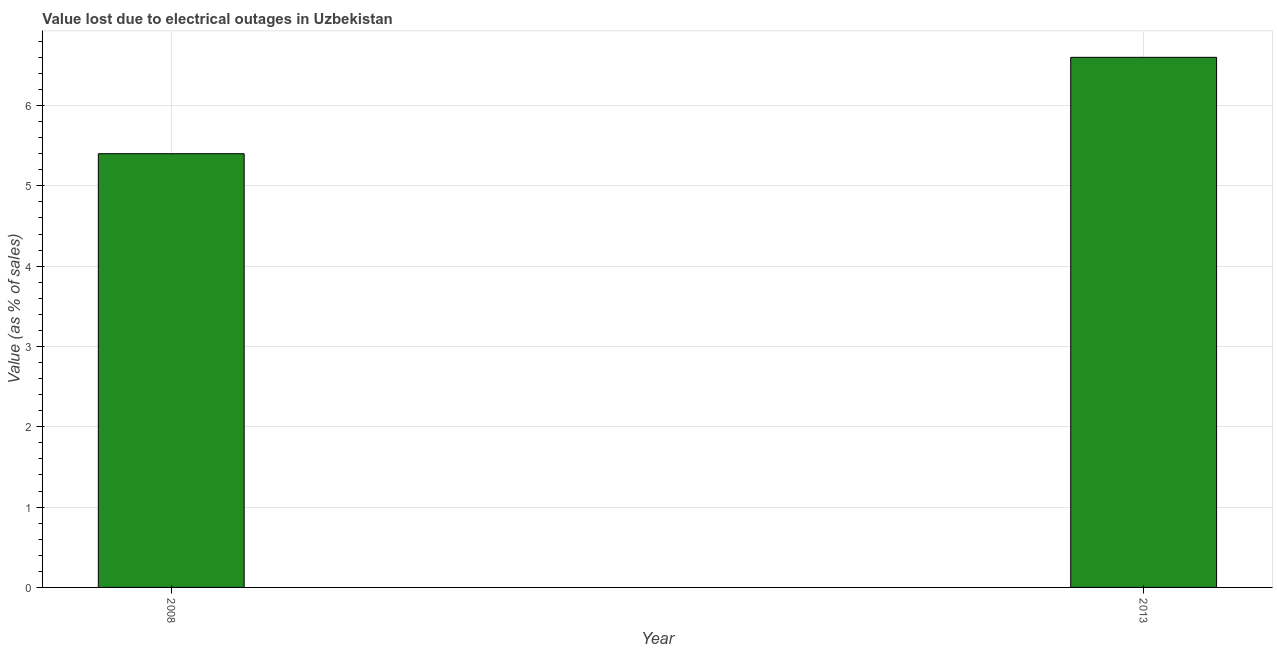Does the graph contain any zero values?
Your answer should be very brief. No. What is the title of the graph?
Offer a very short reply. Value lost due to electrical outages in Uzbekistan. What is the label or title of the X-axis?
Make the answer very short. Year. What is the label or title of the Y-axis?
Offer a very short reply. Value (as % of sales). What is the value lost due to electrical outages in 2013?
Ensure brevity in your answer.  6.6. Across all years, what is the maximum value lost due to electrical outages?
Your answer should be very brief. 6.6. Across all years, what is the minimum value lost due to electrical outages?
Offer a terse response. 5.4. In which year was the value lost due to electrical outages minimum?
Keep it short and to the point. 2008. What is the sum of the value lost due to electrical outages?
Your response must be concise. 12. What is the average value lost due to electrical outages per year?
Offer a very short reply. 6. Do a majority of the years between 2008 and 2013 (inclusive) have value lost due to electrical outages greater than 5.4 %?
Provide a succinct answer. No. What is the ratio of the value lost due to electrical outages in 2008 to that in 2013?
Ensure brevity in your answer.  0.82. Is the value lost due to electrical outages in 2008 less than that in 2013?
Offer a very short reply. Yes. In how many years, is the value lost due to electrical outages greater than the average value lost due to electrical outages taken over all years?
Provide a succinct answer. 1. What is the difference between two consecutive major ticks on the Y-axis?
Ensure brevity in your answer.  1. Are the values on the major ticks of Y-axis written in scientific E-notation?
Make the answer very short. No. What is the difference between the Value (as % of sales) in 2008 and 2013?
Your answer should be compact. -1.2. What is the ratio of the Value (as % of sales) in 2008 to that in 2013?
Give a very brief answer. 0.82. 